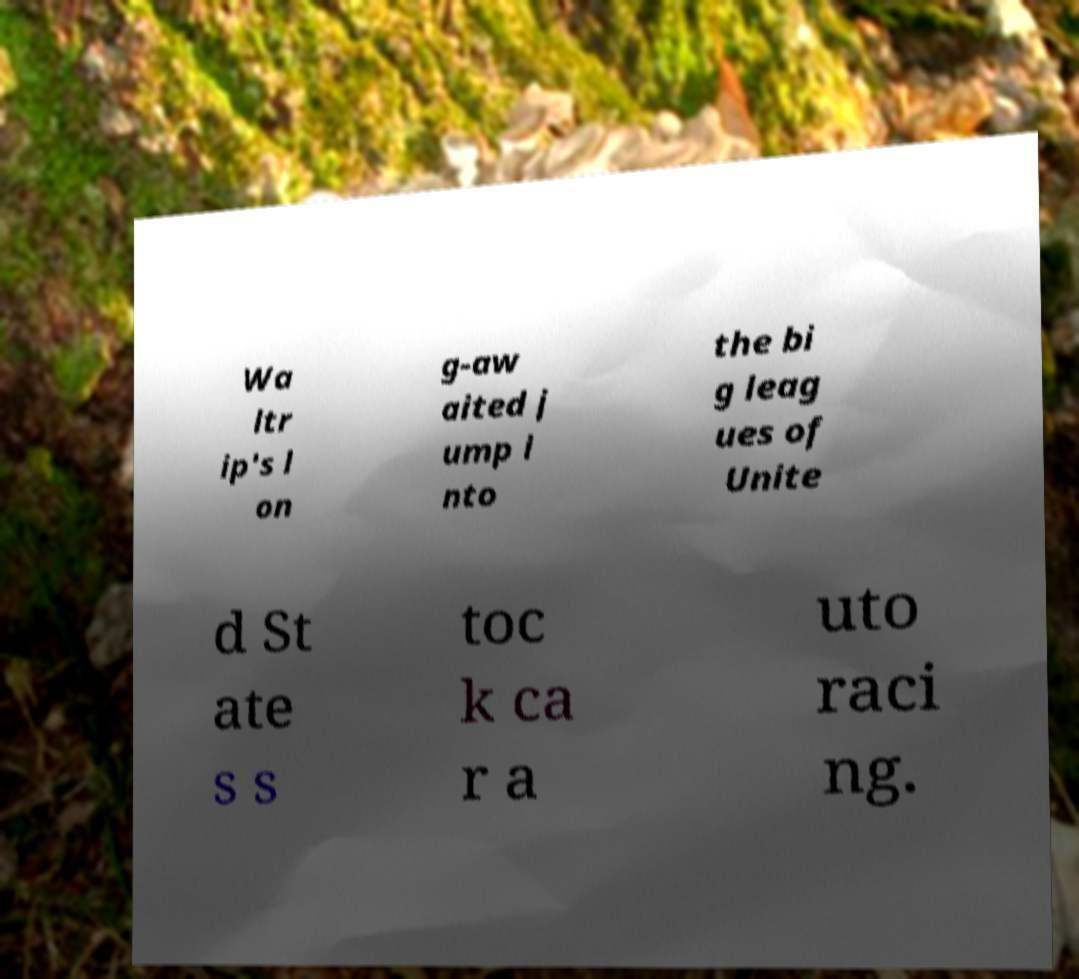For documentation purposes, I need the text within this image transcribed. Could you provide that? Wa ltr ip's l on g-aw aited j ump i nto the bi g leag ues of Unite d St ate s s toc k ca r a uto raci ng. 